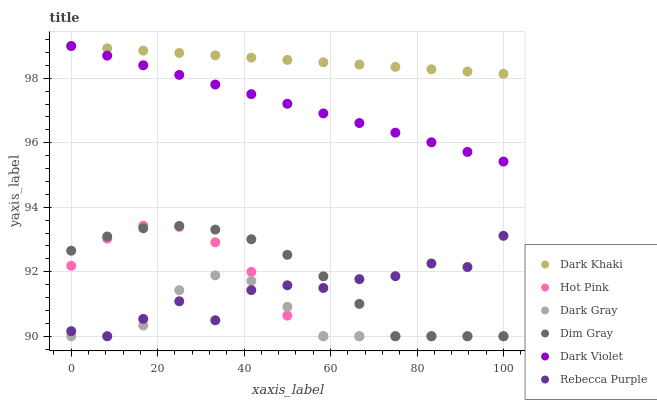Does Dark Gray have the minimum area under the curve?
Answer yes or no. Yes. Does Dark Khaki have the maximum area under the curve?
Answer yes or no. Yes. Does Dim Gray have the minimum area under the curve?
Answer yes or no. No. Does Dim Gray have the maximum area under the curve?
Answer yes or no. No. Is Dark Violet the smoothest?
Answer yes or no. Yes. Is Rebecca Purple the roughest?
Answer yes or no. Yes. Is Dim Gray the smoothest?
Answer yes or no. No. Is Dim Gray the roughest?
Answer yes or no. No. Does Dark Gray have the lowest value?
Answer yes or no. Yes. Does Dark Violet have the lowest value?
Answer yes or no. No. Does Dark Khaki have the highest value?
Answer yes or no. Yes. Does Dim Gray have the highest value?
Answer yes or no. No. Is Rebecca Purple less than Dark Violet?
Answer yes or no. Yes. Is Dark Khaki greater than Dim Gray?
Answer yes or no. Yes. Does Hot Pink intersect Dim Gray?
Answer yes or no. Yes. Is Hot Pink less than Dim Gray?
Answer yes or no. No. Is Hot Pink greater than Dim Gray?
Answer yes or no. No. Does Rebecca Purple intersect Dark Violet?
Answer yes or no. No. 